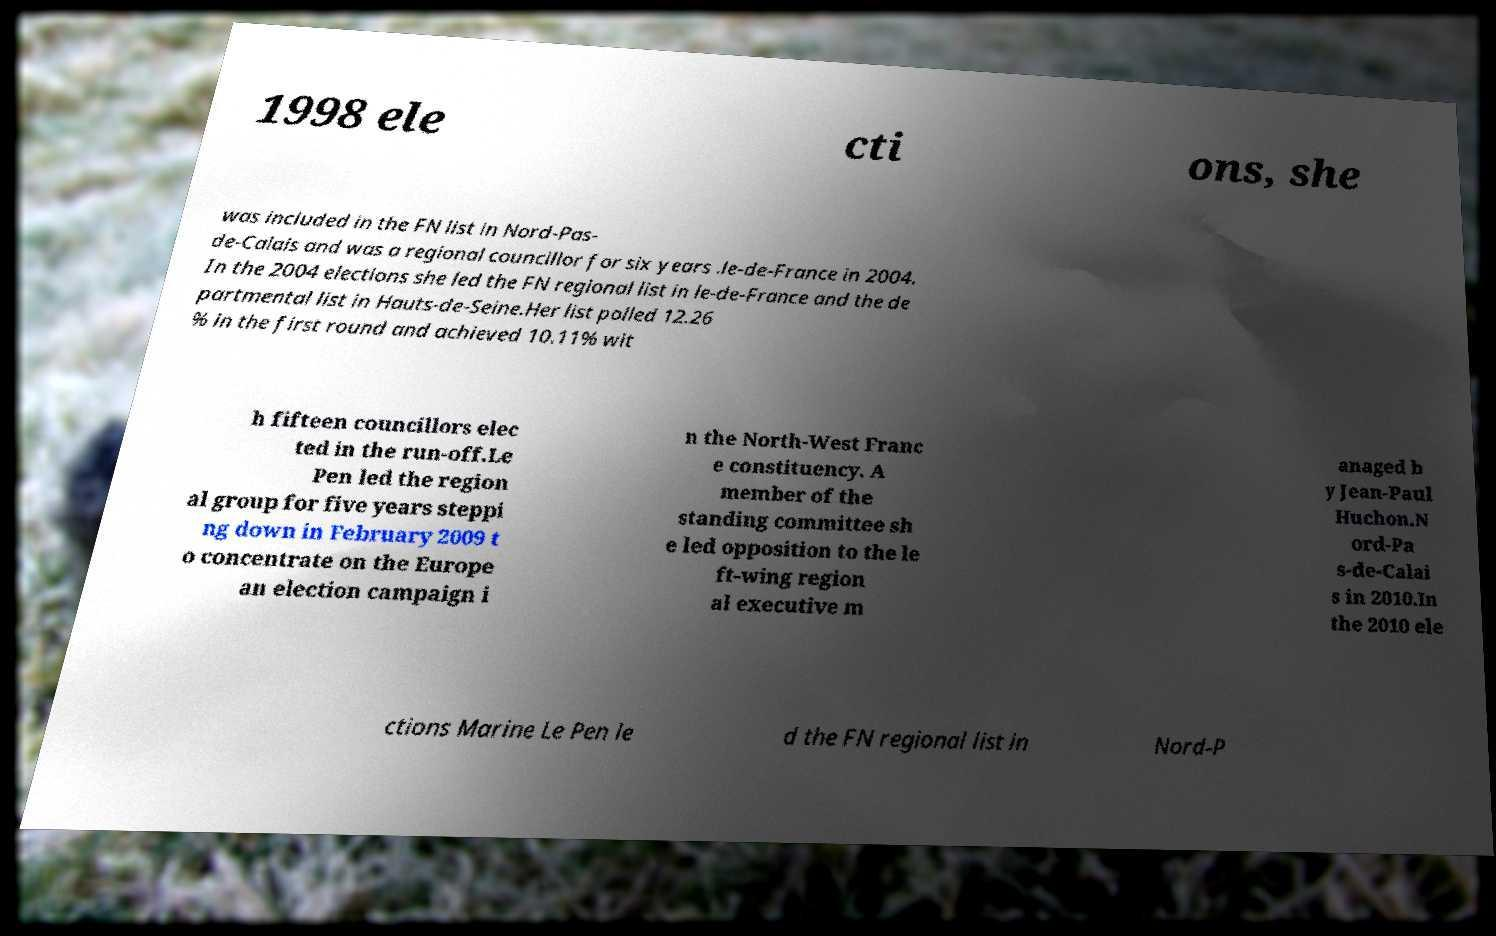What messages or text are displayed in this image? I need them in a readable, typed format. 1998 ele cti ons, she was included in the FN list in Nord-Pas- de-Calais and was a regional councillor for six years .le-de-France in 2004. In the 2004 elections she led the FN regional list in le-de-France and the de partmental list in Hauts-de-Seine.Her list polled 12.26 % in the first round and achieved 10.11% wit h fifteen councillors elec ted in the run-off.Le Pen led the region al group for five years steppi ng down in February 2009 t o concentrate on the Europe an election campaign i n the North-West Franc e constituency. A member of the standing committee sh e led opposition to the le ft-wing region al executive m anaged b y Jean-Paul Huchon.N ord-Pa s-de-Calai s in 2010.In the 2010 ele ctions Marine Le Pen le d the FN regional list in Nord-P 